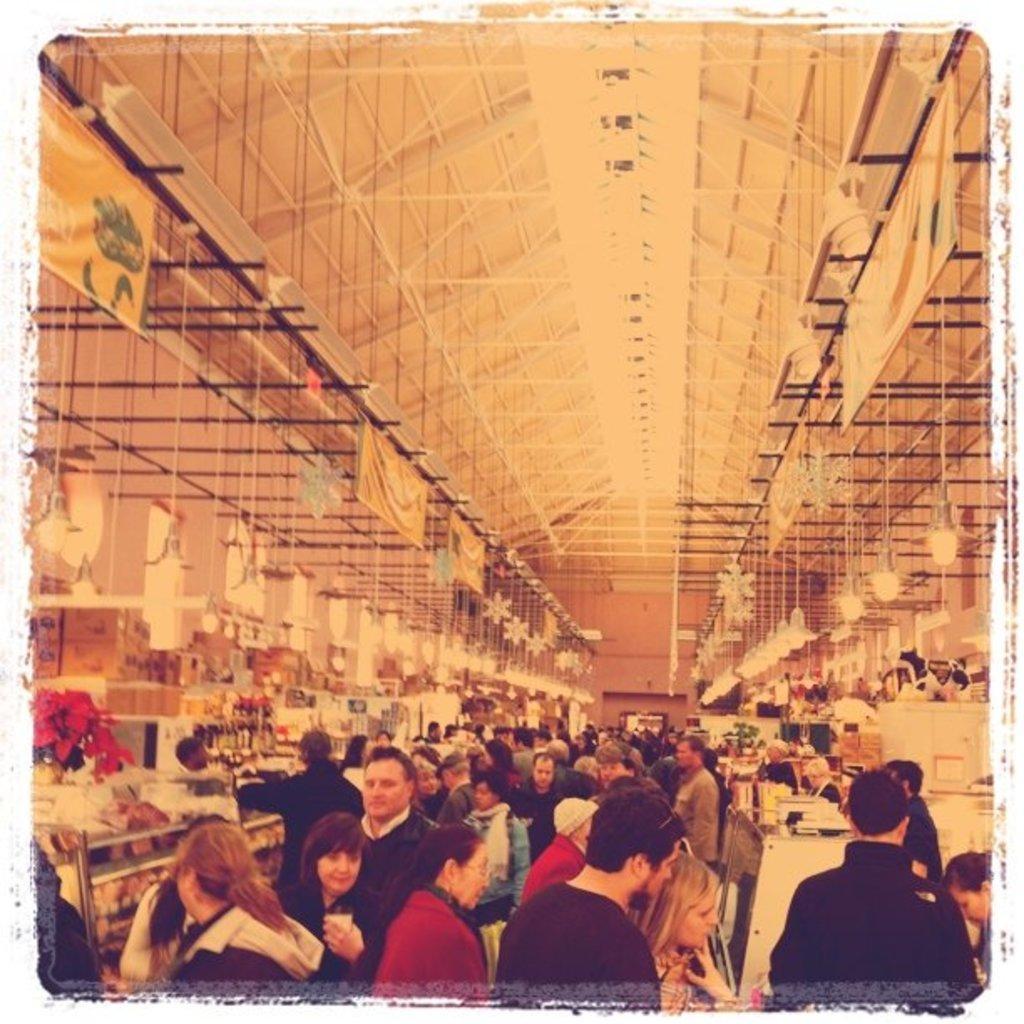In one or two sentences, can you explain what this image depicts? The picture is taken inside a hall. There are many shops. Many many people are there inside the hall. On the top there are lights, banners. 